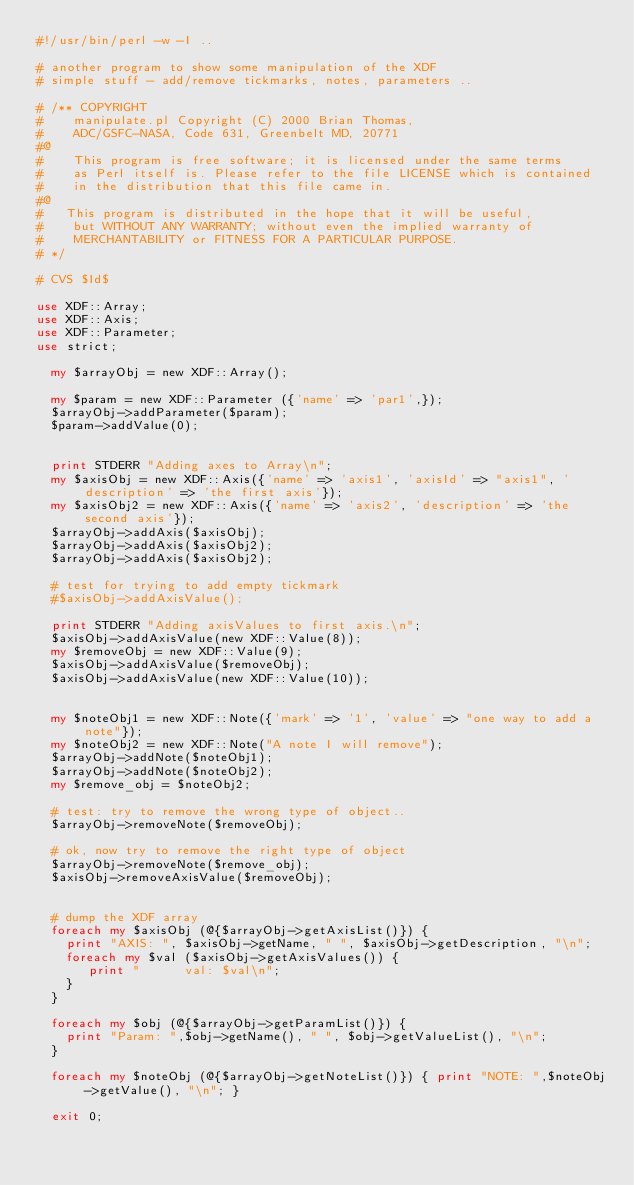<code> <loc_0><loc_0><loc_500><loc_500><_Perl_>#!/usr/bin/perl -w -I ..

# another program to show some manipulation of the XDF
# simple stuff - add/remove tickmarks, notes, parameters .. 

# /** COPYRIGHT
#    manipulate.pl Copyright (C) 2000 Brian Thomas,
#    ADC/GSFC-NASA, Code 631, Greenbelt MD, 20771
#@ 
#    This program is free software; it is licensed under the same terms
#    as Perl itself is. Please refer to the file LICENSE which is contained
#    in the distribution that this file came in.
#@ 
#   This program is distributed in the hope that it will be useful,
#    but WITHOUT ANY WARRANTY; without even the implied warranty of
#    MERCHANTABILITY or FITNESS FOR A PARTICULAR PURPOSE.  
# */

# CVS $Id$

use XDF::Array;
use XDF::Axis;
use XDF::Parameter;
use strict;

  my $arrayObj = new XDF::Array();

  my $param = new XDF::Parameter ({'name' => 'par1',}); 
  $arrayObj->addParameter($param);
  $param->addValue(0);
   

  print STDERR "Adding axes to Array\n";
  my $axisObj = new XDF::Axis({'name' => 'axis1', 'axisId' => "axis1", 'description' => 'the first axis'});
  my $axisObj2 = new XDF::Axis({'name' => 'axis2', 'description' => 'the second axis'});
  $arrayObj->addAxis($axisObj);
  $arrayObj->addAxis($axisObj2);
  $arrayObj->addAxis($axisObj2);

  # test for trying to add empty tickmark
  #$axisObj->addAxisValue(); 

  print STDERR "Adding axisValues to first axis.\n";
  $axisObj->addAxisValue(new XDF::Value(8)); 
  my $removeObj = new XDF::Value(9); 
  $axisObj->addAxisValue($removeObj);
  $axisObj->addAxisValue(new XDF::Value(10)); 


  my $noteObj1 = new XDF::Note({'mark' => '1', 'value' => "one way to add a note"});
  my $noteObj2 = new XDF::Note("A note I will remove");
  $arrayObj->addNote($noteObj1);
  $arrayObj->addNote($noteObj2);
  my $remove_obj = $noteObj2;

  # test: try to remove the wrong type of object..
  $arrayObj->removeNote($removeObj);

  # ok, now try to remove the right type of object
  $arrayObj->removeNote($remove_obj);
  $axisObj->removeAxisValue($removeObj);


  # dump the XDF array
  foreach my $axisObj (@{$arrayObj->getAxisList()}) {
    print "AXIS: ", $axisObj->getName, " ", $axisObj->getDescription, "\n";
    foreach my $val ($axisObj->getAxisValues()) {
       print "      val: $val\n";
    }
  }

  foreach my $obj (@{$arrayObj->getParamList()}) {
    print "Param: ",$obj->getName(), " ", $obj->getValueList(), "\n";
  }

  foreach my $noteObj (@{$arrayObj->getNoteList()}) { print "NOTE: ",$noteObj->getValue(), "\n"; }

  exit 0;
</code> 